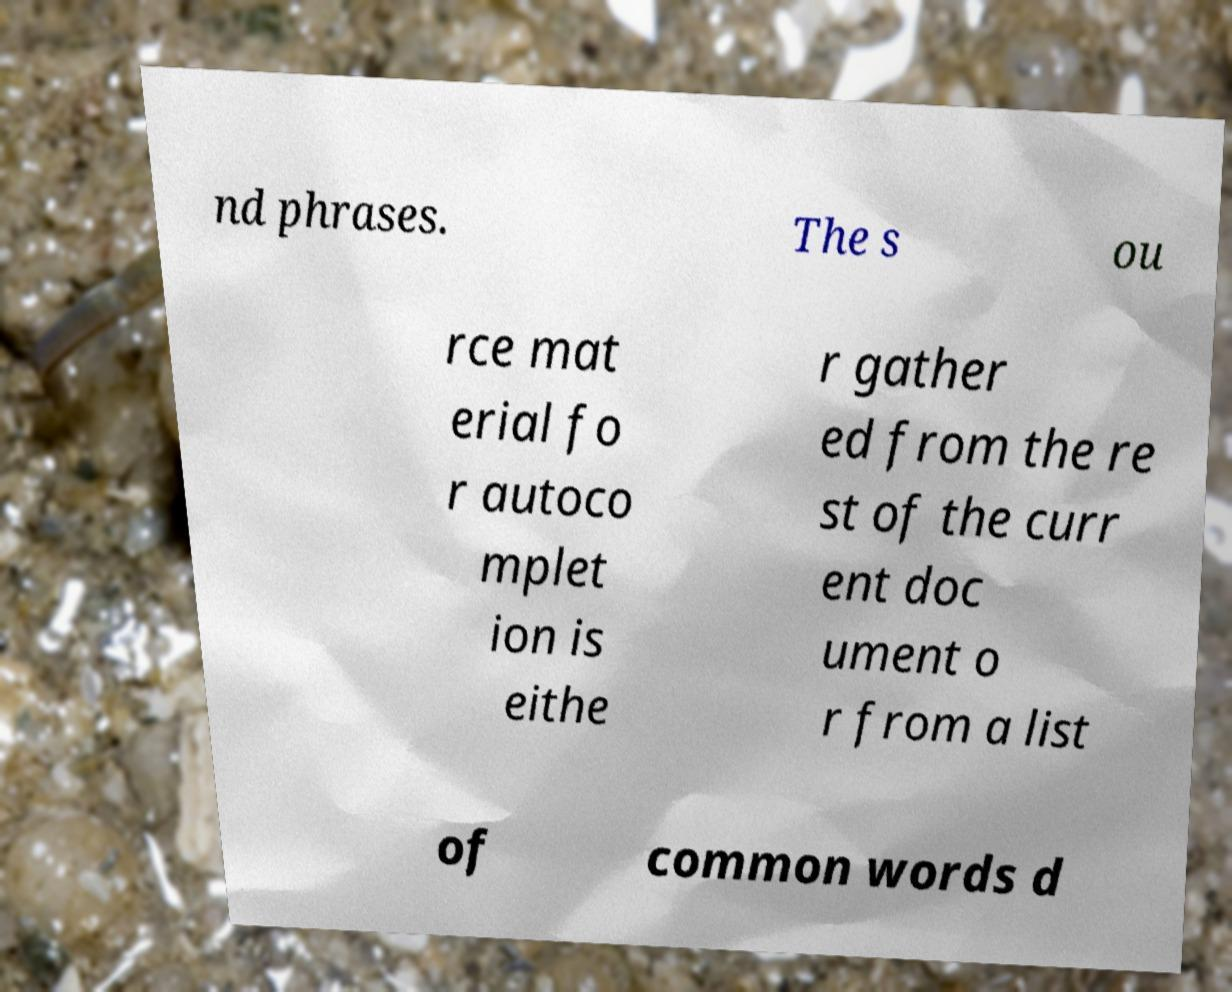Please identify and transcribe the text found in this image. nd phrases. The s ou rce mat erial fo r autoco mplet ion is eithe r gather ed from the re st of the curr ent doc ument o r from a list of common words d 